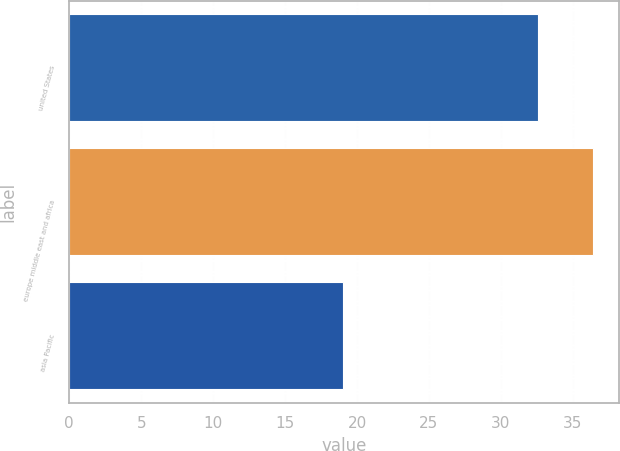Convert chart to OTSL. <chart><loc_0><loc_0><loc_500><loc_500><bar_chart><fcel>united States<fcel>europe middle east and africa<fcel>asia Pacific<nl><fcel>32.6<fcel>36.4<fcel>19<nl></chart> 